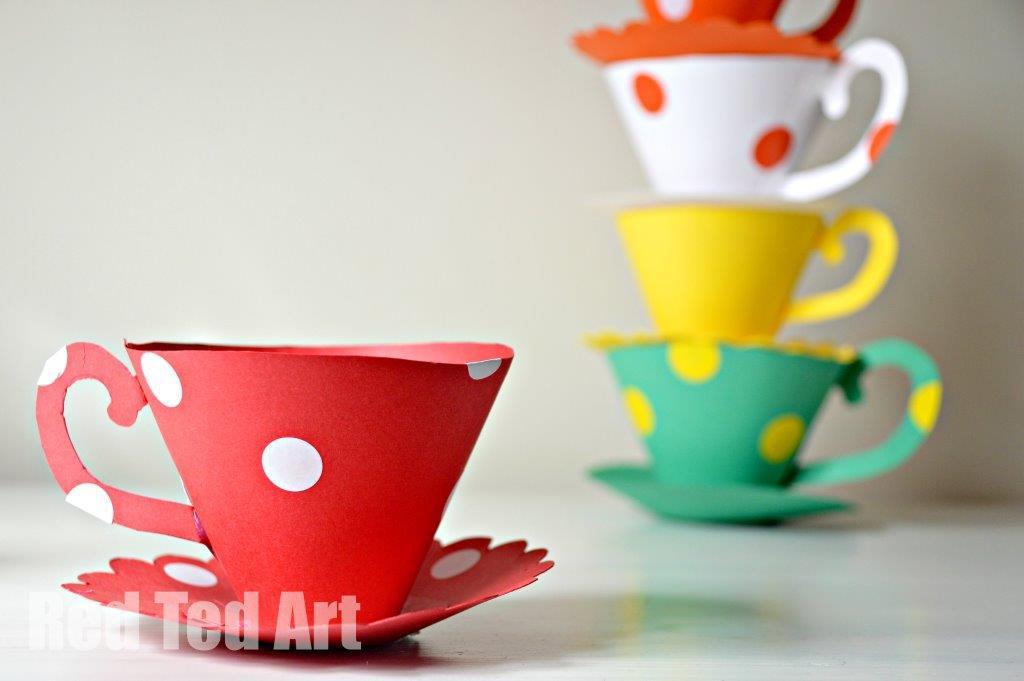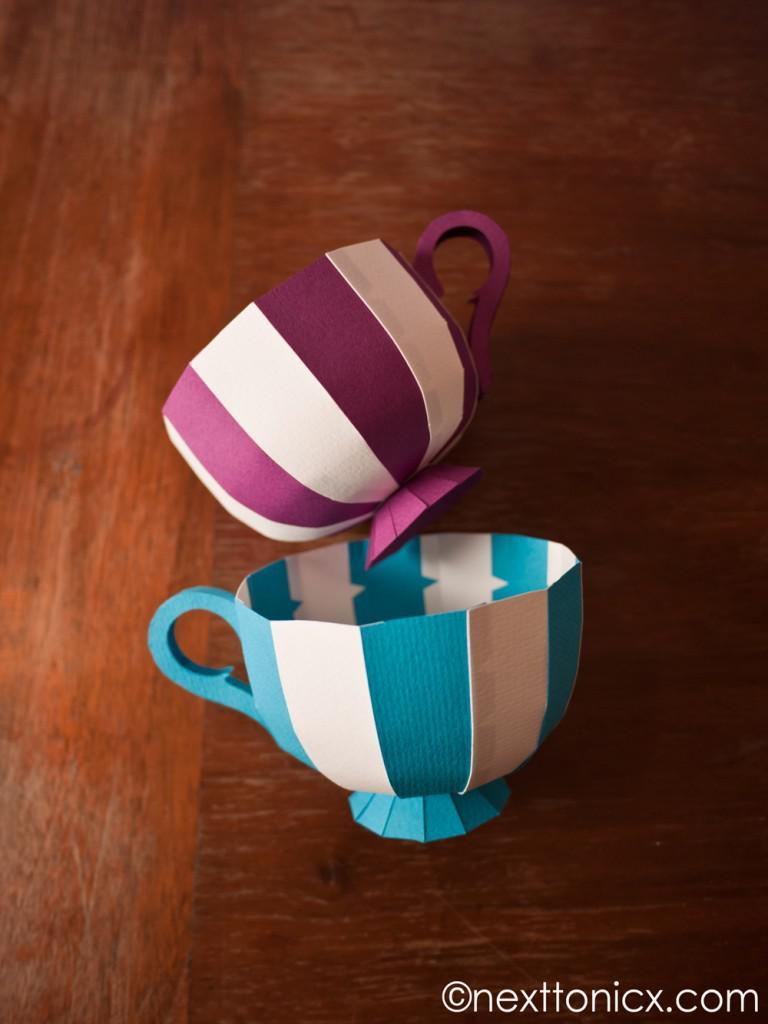The first image is the image on the left, the second image is the image on the right. For the images shown, is this caption "There are multiple paper cups on the left, but only one on the right." true? Answer yes or no. No. 